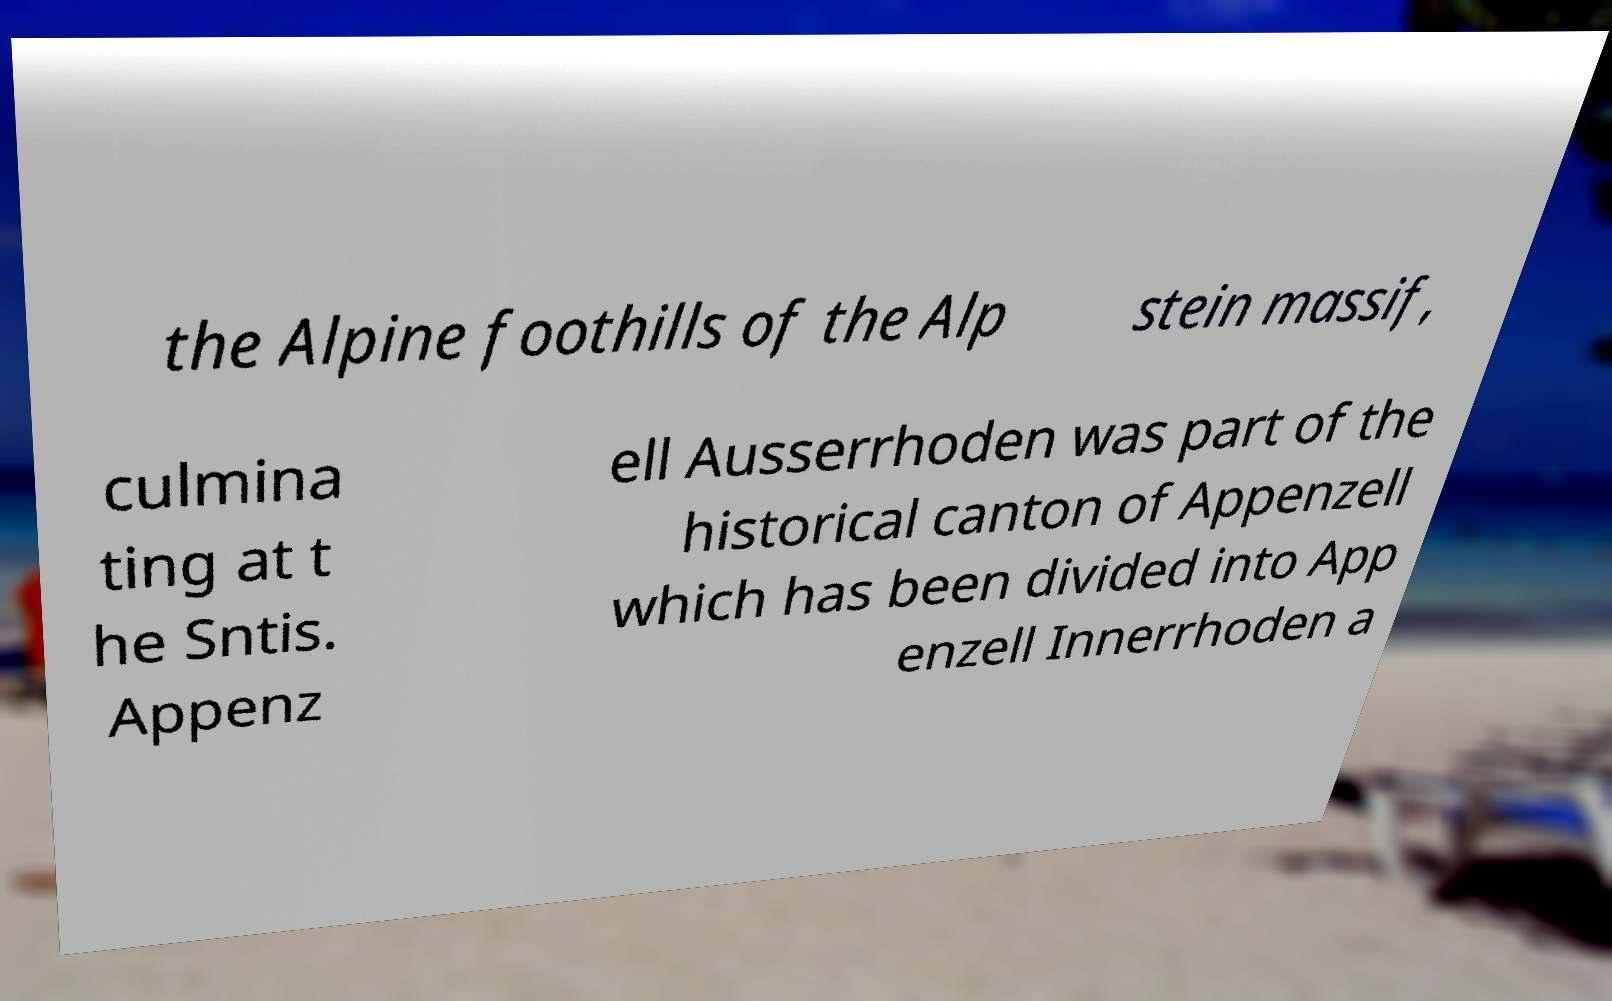What messages or text are displayed in this image? I need them in a readable, typed format. the Alpine foothills of the Alp stein massif, culmina ting at t he Sntis. Appenz ell Ausserrhoden was part of the historical canton of Appenzell which has been divided into App enzell Innerrhoden a 